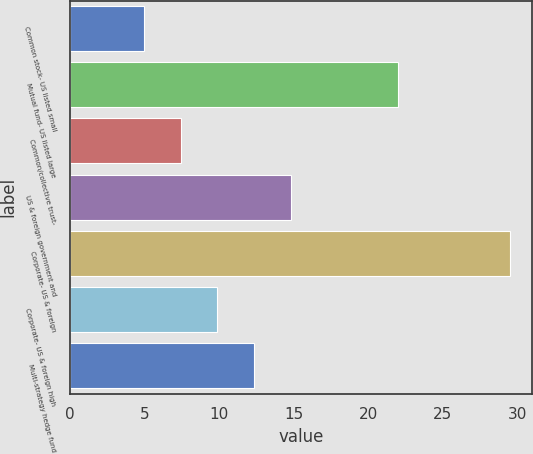Convert chart to OTSL. <chart><loc_0><loc_0><loc_500><loc_500><bar_chart><fcel>Common stock- US listed small<fcel>Mutual fund- US listed large<fcel>Common/collective trust-<fcel>US & foreign government and<fcel>Corporate- US & foreign<fcel>Corporate- US & foreign high<fcel>Multi-strategy hedge fund<nl><fcel>5<fcel>22<fcel>7.45<fcel>14.8<fcel>29.5<fcel>9.9<fcel>12.35<nl></chart> 